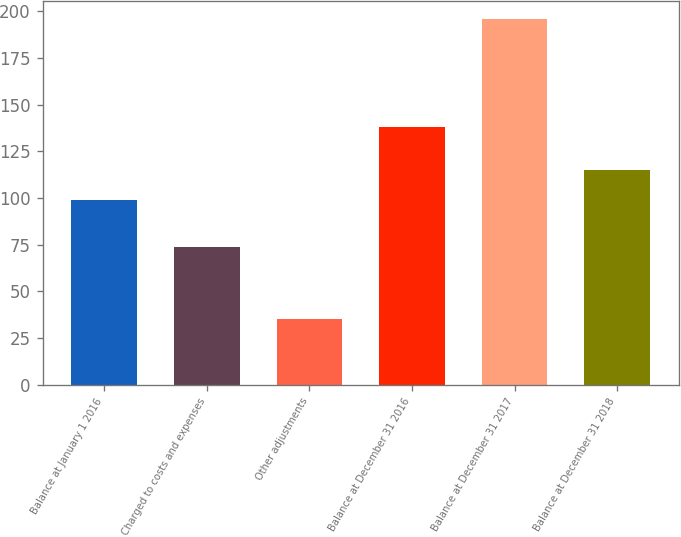<chart> <loc_0><loc_0><loc_500><loc_500><bar_chart><fcel>Balance at January 1 2016<fcel>Charged to costs and expenses<fcel>Other adjustments<fcel>Balance at December 31 2016<fcel>Balance at December 31 2017<fcel>Balance at December 31 2018<nl><fcel>99<fcel>74<fcel>35<fcel>138<fcel>196<fcel>115.1<nl></chart> 